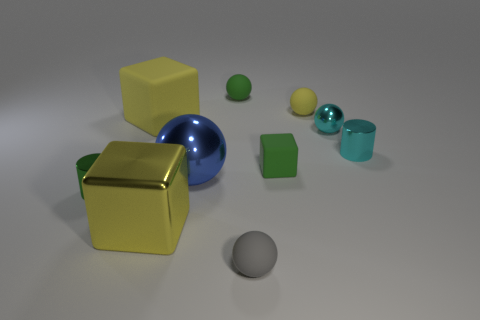What number of other things are there of the same color as the big matte thing?
Your answer should be very brief. 2. There is a big object that is made of the same material as the gray sphere; what shape is it?
Your answer should be very brief. Cube. What number of matte objects are either small cyan balls or large green things?
Offer a terse response. 0. There is a metallic sphere that is in front of the metallic sphere that is behind the big ball; what number of large spheres are right of it?
Keep it short and to the point. 0. Do the green rubber thing that is behind the cyan cylinder and the rubber sphere in front of the green cylinder have the same size?
Offer a terse response. Yes. There is a cyan object that is the same shape as the large blue metallic thing; what is it made of?
Provide a succinct answer. Metal. How many small things are balls or metal things?
Keep it short and to the point. 6. What material is the cyan cylinder?
Keep it short and to the point. Metal. What is the object that is behind the yellow rubber cube and on the right side of the gray object made of?
Offer a very short reply. Rubber. There is a big rubber cube; is its color the same as the big thing that is in front of the large blue metal object?
Your answer should be very brief. Yes. 